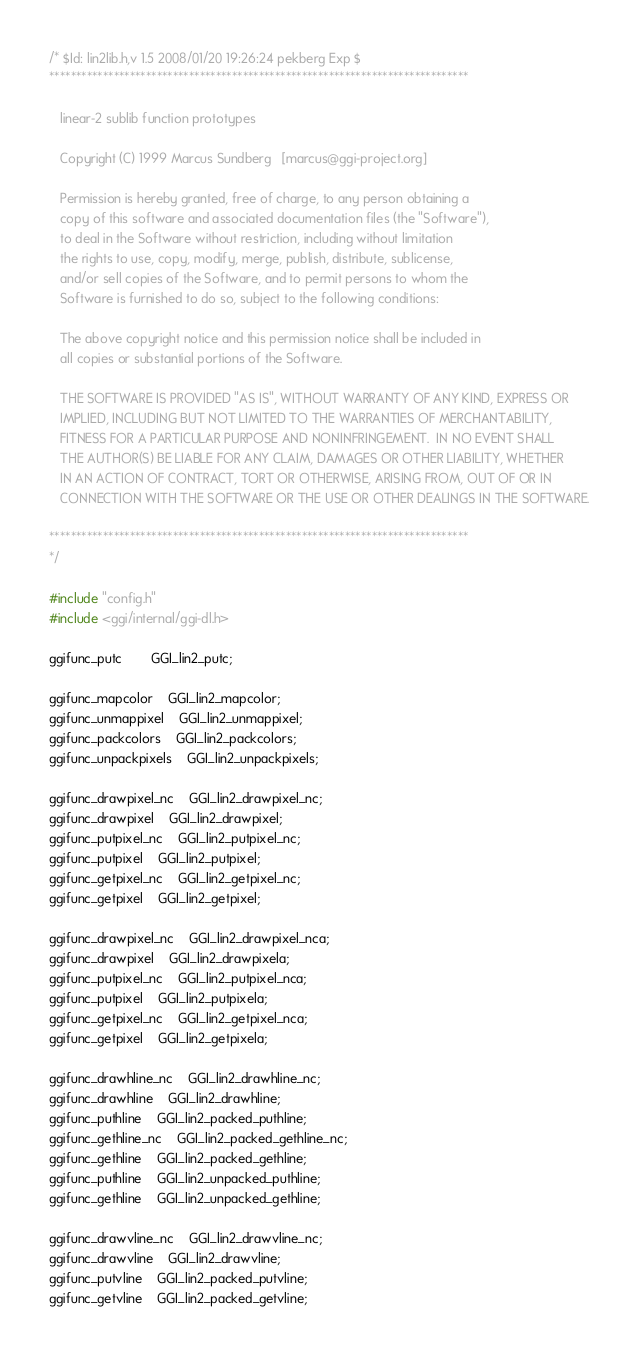Convert code to text. <code><loc_0><loc_0><loc_500><loc_500><_C_>/* $Id: lin2lib.h,v 1.5 2008/01/20 19:26:24 pekberg Exp $
******************************************************************************

   linear-2 sublib function prototypes

   Copyright (C) 1999 Marcus Sundberg	[marcus@ggi-project.org]

   Permission is hereby granted, free of charge, to any person obtaining a
   copy of this software and associated documentation files (the "Software"),
   to deal in the Software without restriction, including without limitation
   the rights to use, copy, modify, merge, publish, distribute, sublicense,
   and/or sell copies of the Software, and to permit persons to whom the
   Software is furnished to do so, subject to the following conditions:

   The above copyright notice and this permission notice shall be included in
   all copies or substantial portions of the Software.

   THE SOFTWARE IS PROVIDED "AS IS", WITHOUT WARRANTY OF ANY KIND, EXPRESS OR
   IMPLIED, INCLUDING BUT NOT LIMITED TO THE WARRANTIES OF MERCHANTABILITY,
   FITNESS FOR A PARTICULAR PURPOSE AND NONINFRINGEMENT.  IN NO EVENT SHALL
   THE AUTHOR(S) BE LIABLE FOR ANY CLAIM, DAMAGES OR OTHER LIABILITY, WHETHER
   IN AN ACTION OF CONTRACT, TORT OR OTHERWISE, ARISING FROM, OUT OF OR IN
   CONNECTION WITH THE SOFTWARE OR THE USE OR OTHER DEALINGS IN THE SOFTWARE.

******************************************************************************
*/

#include "config.h"
#include <ggi/internal/ggi-dl.h>

ggifunc_putc		GGI_lin2_putc;

ggifunc_mapcolor	GGI_lin2_mapcolor;
ggifunc_unmappixel	GGI_lin2_unmappixel;
ggifunc_packcolors	GGI_lin2_packcolors;
ggifunc_unpackpixels	GGI_lin2_unpackpixels;

ggifunc_drawpixel_nc	GGI_lin2_drawpixel_nc;
ggifunc_drawpixel	GGI_lin2_drawpixel;
ggifunc_putpixel_nc	GGI_lin2_putpixel_nc;
ggifunc_putpixel	GGI_lin2_putpixel;
ggifunc_getpixel_nc	GGI_lin2_getpixel_nc;
ggifunc_getpixel	GGI_lin2_getpixel;

ggifunc_drawpixel_nc	GGI_lin2_drawpixel_nca;
ggifunc_drawpixel	GGI_lin2_drawpixela;
ggifunc_putpixel_nc	GGI_lin2_putpixel_nca;
ggifunc_putpixel	GGI_lin2_putpixela;
ggifunc_getpixel_nc	GGI_lin2_getpixel_nca;
ggifunc_getpixel	GGI_lin2_getpixela;

ggifunc_drawhline_nc	GGI_lin2_drawhline_nc;
ggifunc_drawhline	GGI_lin2_drawhline;
ggifunc_puthline	GGI_lin2_packed_puthline;
ggifunc_gethline_nc	GGI_lin2_packed_gethline_nc;
ggifunc_gethline	GGI_lin2_packed_gethline;
ggifunc_puthline	GGI_lin2_unpacked_puthline;
ggifunc_gethline	GGI_lin2_unpacked_gethline;

ggifunc_drawvline_nc	GGI_lin2_drawvline_nc;
ggifunc_drawvline	GGI_lin2_drawvline;
ggifunc_putvline	GGI_lin2_packed_putvline;
ggifunc_getvline	GGI_lin2_packed_getvline;</code> 